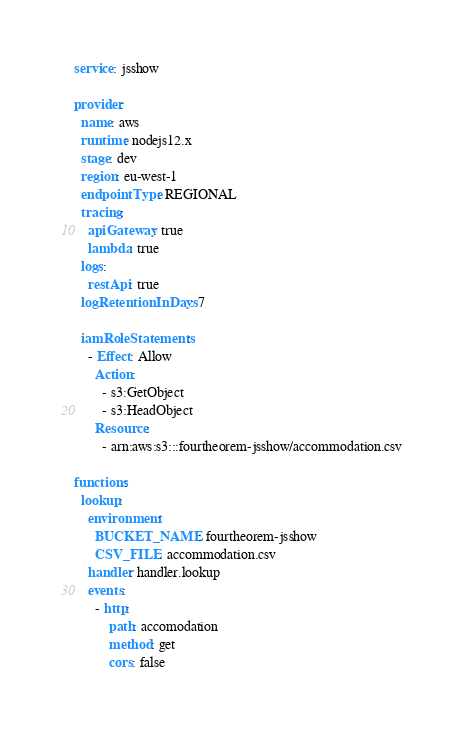<code> <loc_0><loc_0><loc_500><loc_500><_YAML_>service: jsshow

provider:
  name: aws
  runtime: nodejs12.x
  stage: dev
  region: eu-west-1
  endpointType: REGIONAL
  tracing:
    apiGateway: true
    lambda: true
  logs:
    restApi: true
  logRetentionInDays: 7

  iamRoleStatements:
    - Effect: Allow
      Action:
        - s3:GetObject
        - s3:HeadObject
      Resource:
        - arn:aws:s3:::fourtheorem-jsshow/accommodation.csv

functions:
  lookup:
    environment:
      BUCKET_NAME: fourtheorem-jsshow
      CSV_FILE: accommodation.csv
    handler: handler.lookup
    events:
      - http:
          path: accomodation
          method: get
          cors: false
</code> 